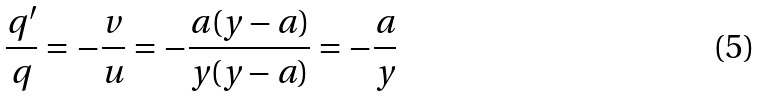<formula> <loc_0><loc_0><loc_500><loc_500>\frac { q ^ { \prime } } { q } = - \frac { v } { u } = - \frac { a ( y - a ) } { y ( y - a ) } = - \frac { a } { y }</formula> 